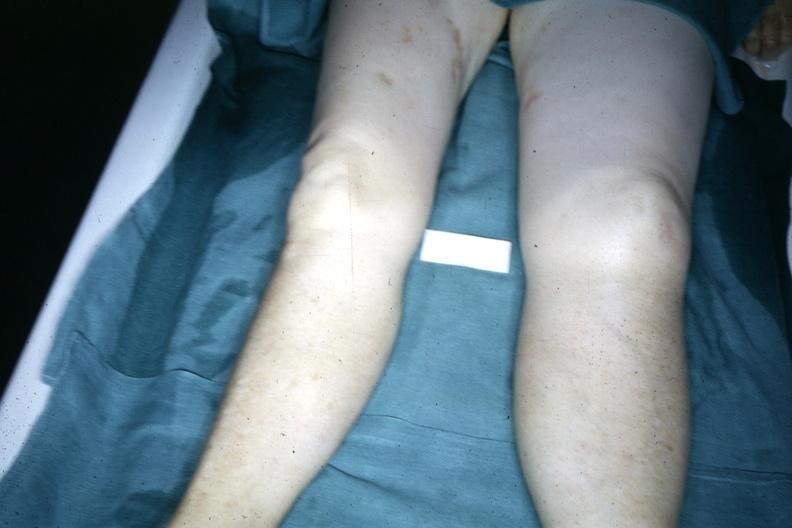s edema present?
Answer the question using a single word or phrase. Yes 